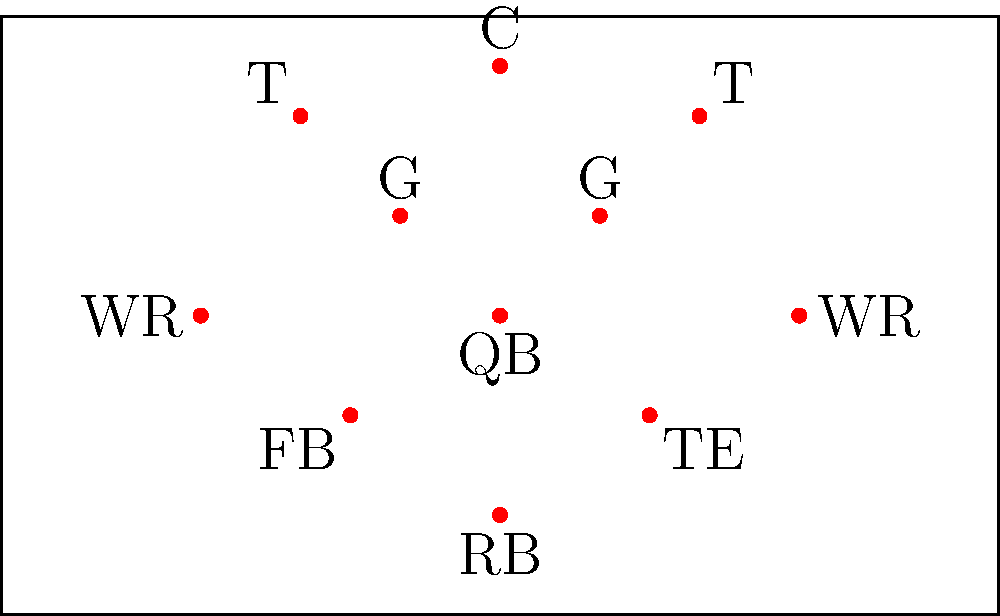Identify the football formation depicted in this aerial diagram. What is notable about the positioning of the running backs in this formation? To identify this formation and its notable features, let's break it down step-by-step:

1. Offensive Line: We see 5 players lined up at the top of the formation (2 Tackles, 2 Guards, and 1 Center), which is standard for most formations.

2. Quarterback (QB): Located directly behind the center, in a position to take the snap.

3. Wide Receivers (WR): Two players are split out wide, one on each side of the formation.

4. Tight End (TE): One player is positioned just off the line, slightly back from the right tackle.

5. Running Backs: This is the key to identifying the formation. We see two players in the backfield behind the QB:
   - One player (RB) is directly behind the QB, about 5-7 yards deep.
   - Another player (FB) is offset to the left, closer to the line of scrimmage than the RB.

This alignment of running backs is characteristic of the "I-Formation," but with a twist. The fullback (FB) is not directly in line with the QB and RB, which would form a true "I." Instead, the FB is offset to one side.

Therefore, this specific formation is known as the "Offset I-Formation" or sometimes called the "Power I-Formation."

What's notable about this RB positioning is that it provides versatility in the running game. The offset fullback can lead block to either side, and the formation doesn't telegraph the direction of the play as clearly as a standard I-Formation might.
Answer: Offset I-Formation 